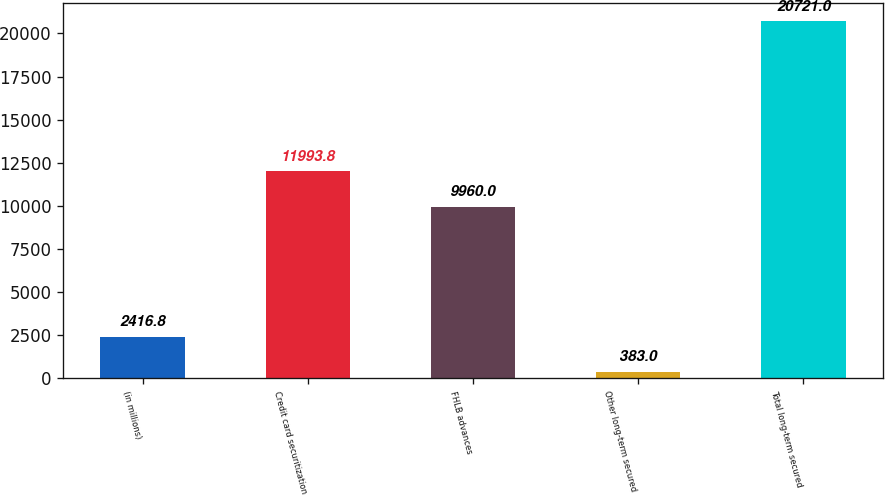Convert chart to OTSL. <chart><loc_0><loc_0><loc_500><loc_500><bar_chart><fcel>(in millions)<fcel>Credit card securitization<fcel>FHLB advances<fcel>Other long-term secured<fcel>Total long-term secured<nl><fcel>2416.8<fcel>11993.8<fcel>9960<fcel>383<fcel>20721<nl></chart> 